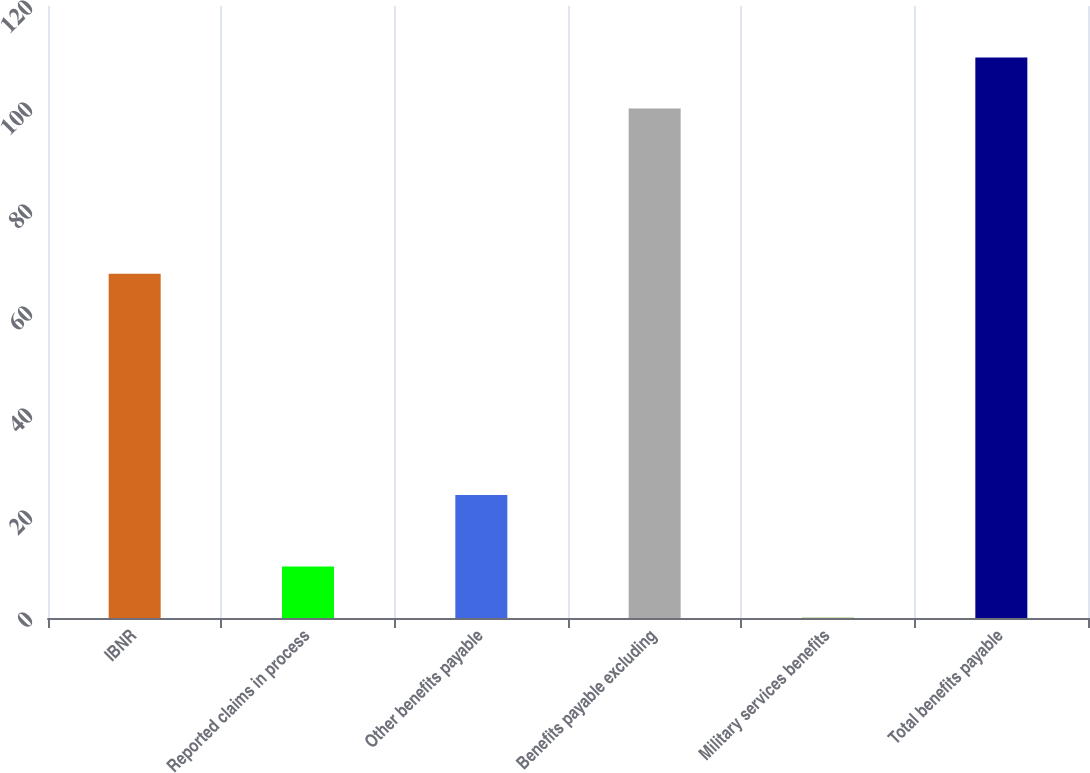<chart> <loc_0><loc_0><loc_500><loc_500><bar_chart><fcel>IBNR<fcel>Reported claims in process<fcel>Other benefits payable<fcel>Benefits payable excluding<fcel>Military services benefits<fcel>Total benefits payable<nl><fcel>67.5<fcel>10.09<fcel>24.1<fcel>99.9<fcel>0.1<fcel>109.89<nl></chart> 